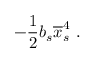Convert formula to latex. <formula><loc_0><loc_0><loc_500><loc_500>- \frac { 1 } { 2 } b _ { s } \overline { x } _ { s \, } ^ { 4 } \, .</formula> 